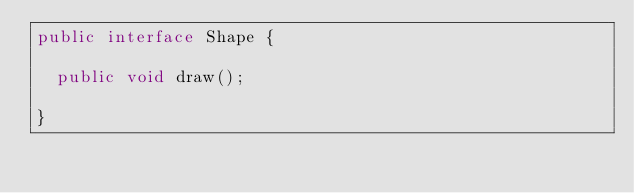Convert code to text. <code><loc_0><loc_0><loc_500><loc_500><_Java_>public interface Shape {

  public void draw();

}
</code> 